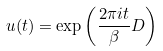<formula> <loc_0><loc_0><loc_500><loc_500>u ( t ) = \exp \left ( \frac { 2 \pi i t } { \beta } D \right )</formula> 